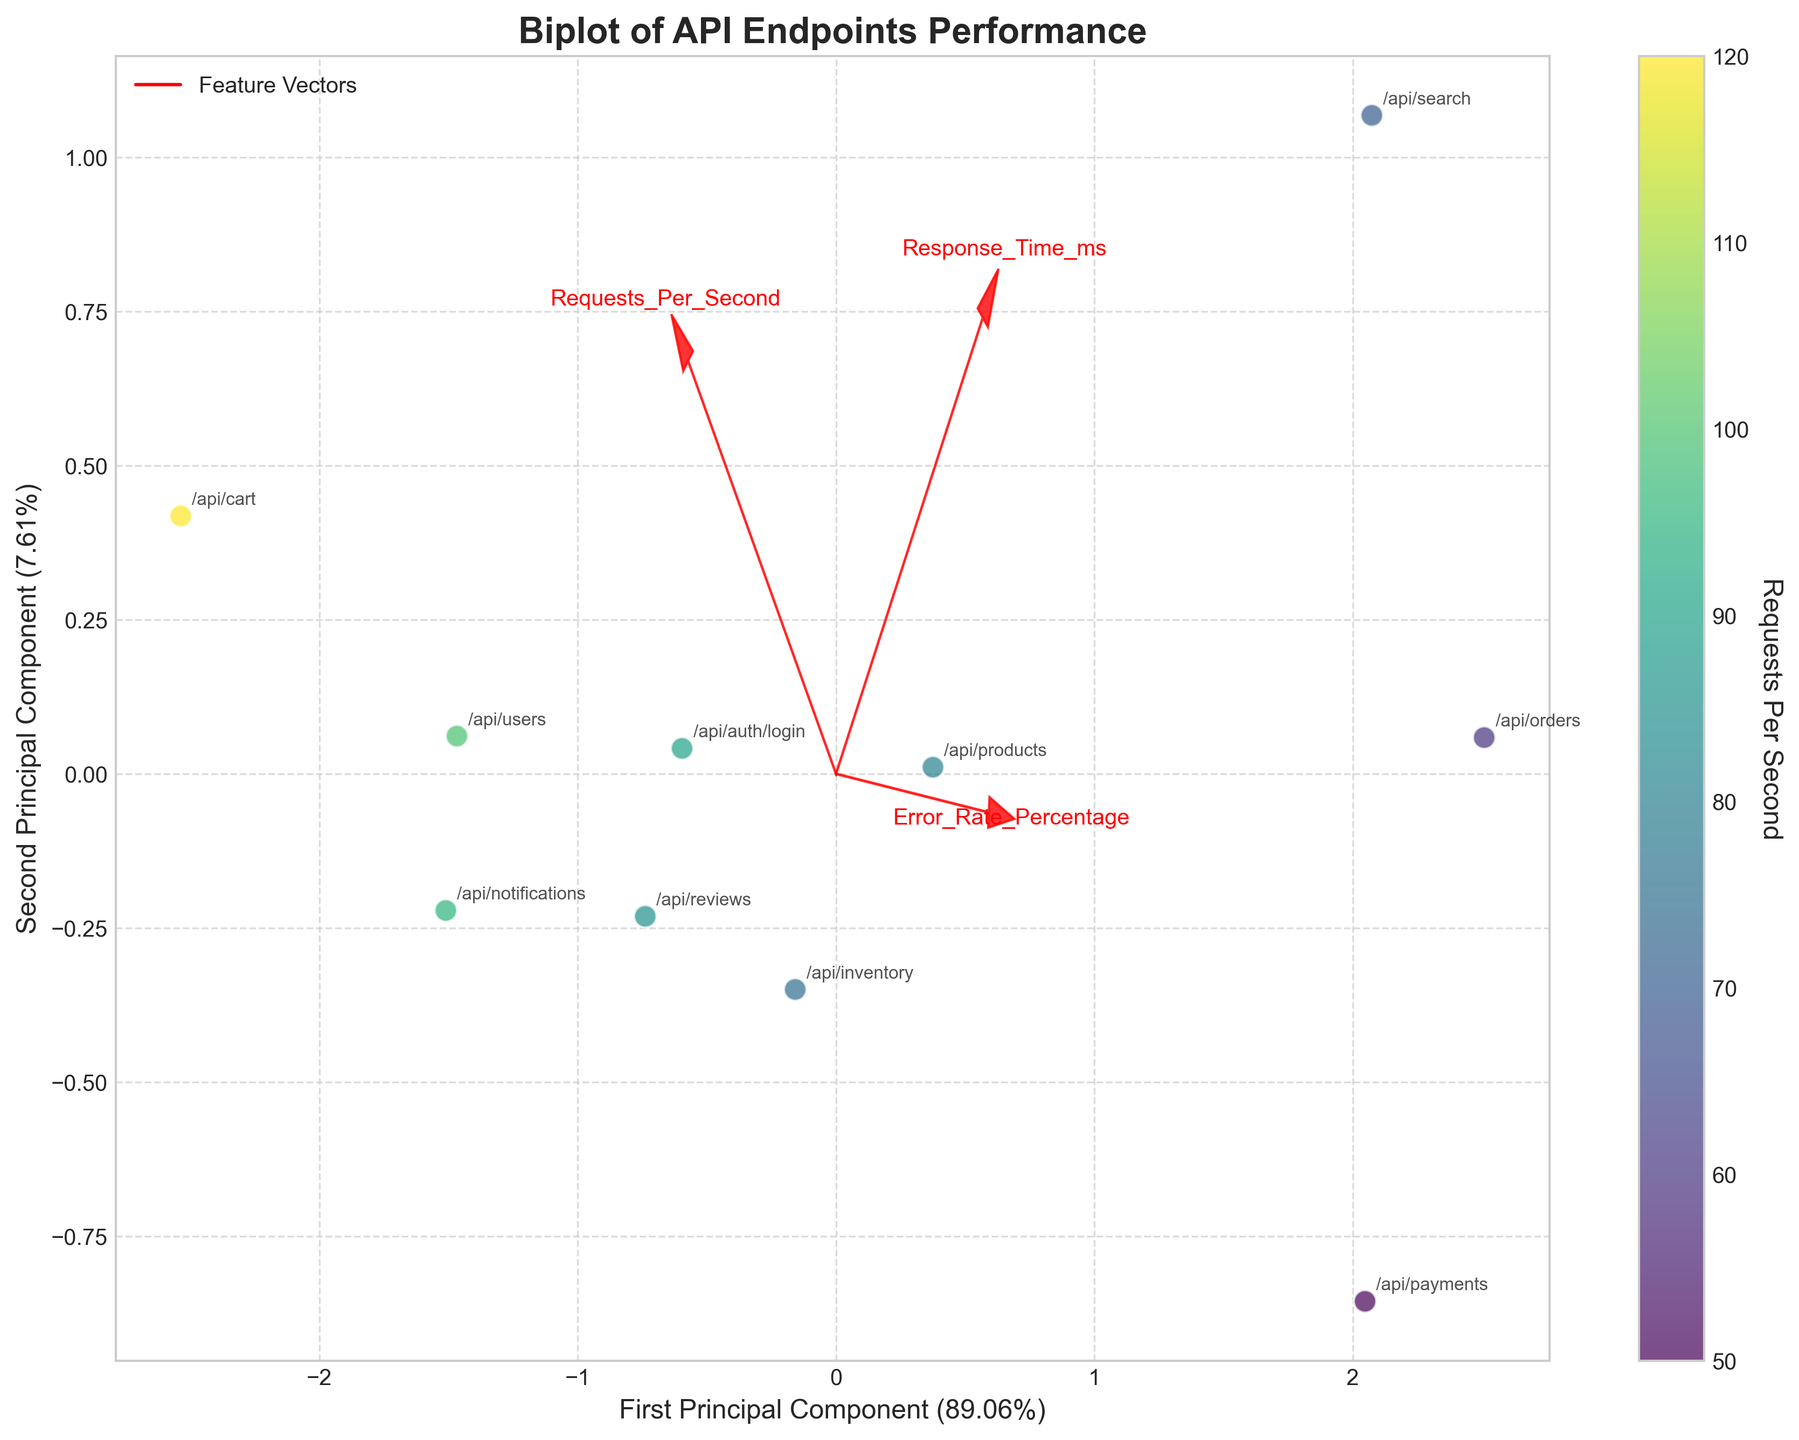Which API endpoint has the highest error rate percentage? By examining the scatter plot, the API endpoint with the highest error rate percentage will be one of the points furthest in the positive direction of the 'Error_Rate_Percentage' vector.
Answer: /api/orders What is the title of the plot? The title of the plot is usually prominent and centered above the plot area.
Answer: Biplot of API Endpoints Performance Which feature vector is the longest? The vector that extends the furthest from the origin indicates the feature with the greatest contribution to the principal components. This can be observed visually by comparing the lengths of the red arrows.
Answer: Response_Time_ms How many API endpoints were analyzed in this plot? Every point represents one API endpoint. By counting all the distinct points scattered across the plot, the total number of analyzed API endpoints can be determined.
Answer: 10 Which API endpoint has the lowest response time? By looking at the position of the points in relation to the 'Response_Time_ms' vector, the endpoint closest to the negative end of the 'Response_Time_ms' vector represents the one with the lowest response time.
Answer: /api/cart Compare the /api/search and /api/auth/login, which one has higher error rate percentage? By checking the positions of /api/search and /api/auth/login along the 'Error_Rate_Percentage' vector, the one further along the positive direction of the vector has a higher error rate percentage.
Answer: /api/search Which API endpoint has the highest requests per second? The color of the scatter points represents the 'Requests Per Second' metric. The point in the brightest hue (highest in the colormap) has the highest requests per second.
Answer: /api/cart How are the features 'Response_Time_ms' and 'Error_Rate_Percentage' related visually? By examining the direction of the feature vectors, we can observe if they point in similar or opposite directions, indicating correlation or lack thereof. In this plot, 'Response_Time_ms' and 'Error_Rate_Percentage' arrows appear to point in similar directions, suggesting a positive correlation.
Answer: Positively correlated Which API endpoint has the maximum response time comparing the data points along the 'Response_Time_ms' vector? The endpoint placed the furthest along the direction of the 'Response_Time_ms' vector would have the maximum response time. By visually inspecting where these endpoints fall on the plot, the endpoint furthest towards the positive end is identified.
Answer: /api/search 